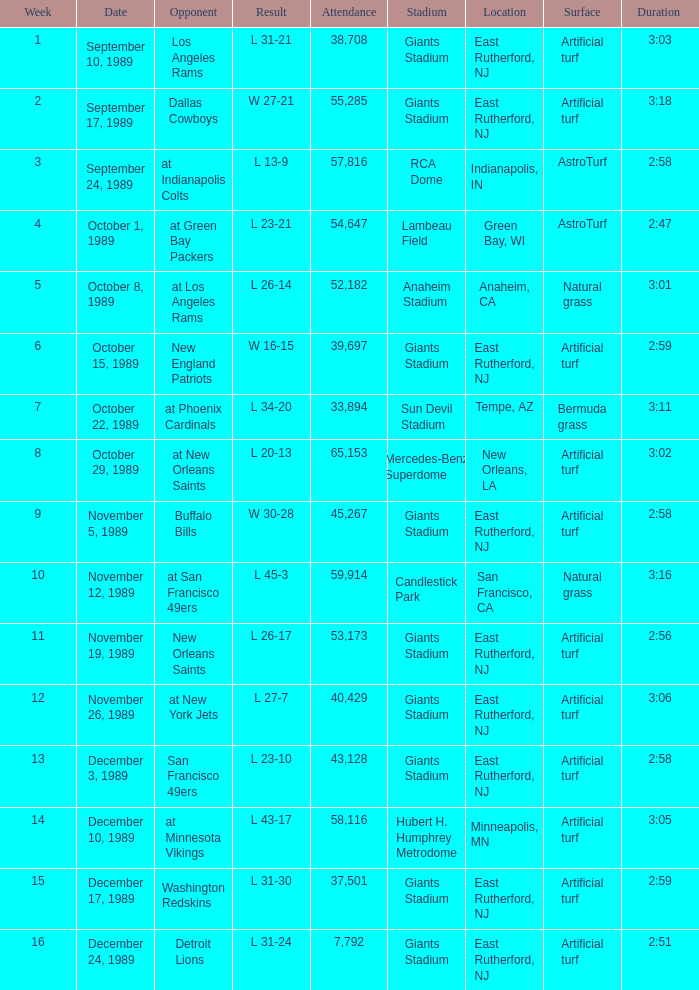Would you be able to parse every entry in this table? {'header': ['Week', 'Date', 'Opponent', 'Result', 'Attendance', 'Stadium', 'Location', 'Surface', 'Duration '], 'rows': [['1', 'September 10, 1989', 'Los Angeles Rams', 'L 31-21', '38,708', 'Giants Stadium', 'East Rutherford, NJ', 'Artificial turf', '3:03'], ['2', 'September 17, 1989', 'Dallas Cowboys', 'W 27-21', '55,285', 'Giants Stadium', 'East Rutherford, NJ', 'Artificial turf', '3:18'], ['3', 'September 24, 1989', 'at Indianapolis Colts', 'L 13-9', '57,816', 'RCA Dome', 'Indianapolis, IN', 'AstroTurf', '2:58'], ['4', 'October 1, 1989', 'at Green Bay Packers', 'L 23-21', '54,647', 'Lambeau Field', 'Green Bay, WI', 'AstroTurf', '2:47'], ['5', 'October 8, 1989', 'at Los Angeles Rams', 'L 26-14', '52,182', 'Anaheim Stadium', 'Anaheim, CA', 'Natural grass', '3:01'], ['6', 'October 15, 1989', 'New England Patriots', 'W 16-15', '39,697', 'Giants Stadium', 'East Rutherford, NJ', 'Artificial turf', '2:59'], ['7', 'October 22, 1989', 'at Phoenix Cardinals', 'L 34-20', '33,894', 'Sun Devil Stadium', 'Tempe, AZ', 'Bermuda grass', '3:11'], ['8', 'October 29, 1989', 'at New Orleans Saints', 'L 20-13', '65,153', 'Mercedes-Benz Superdome', 'New Orleans, LA', 'Artificial turf', '3:02'], ['9', 'November 5, 1989', 'Buffalo Bills', 'W 30-28', '45,267', 'Giants Stadium', 'East Rutherford, NJ', 'Artificial turf', '2:58'], ['10', 'November 12, 1989', 'at San Francisco 49ers', 'L 45-3', '59,914', 'Candlestick Park', 'San Francisco, CA', 'Natural grass', '3:16'], ['11', 'November 19, 1989', 'New Orleans Saints', 'L 26-17', '53,173', 'Giants Stadium', 'East Rutherford, NJ', 'Artificial turf', '2:56'], ['12', 'November 26, 1989', 'at New York Jets', 'L 27-7', '40,429', 'Giants Stadium', 'East Rutherford, NJ', 'Artificial turf', '3:06'], ['13', 'December 3, 1989', 'San Francisco 49ers', 'L 23-10', '43,128', 'Giants Stadium', 'East Rutherford, NJ', 'Artificial turf', '2:58'], ['14', 'December 10, 1989', 'at Minnesota Vikings', 'L 43-17', '58,116', 'Hubert H. Humphrey Metrodome', 'Minneapolis, MN', 'Artificial turf', '3:05'], ['15', 'December 17, 1989', 'Washington Redskins', 'L 31-30', '37,501', 'Giants Stadium', 'East Rutherford, NJ', 'Artificial turf', '2:59'], ['16', 'December 24, 1989', 'Detroit Lions', 'L 31-24', '7,792', 'Giants Stadium', 'East Rutherford, NJ', 'Artificial turf', '2:51']]} On September 10, 1989 how many people attended the game? 38708.0. 